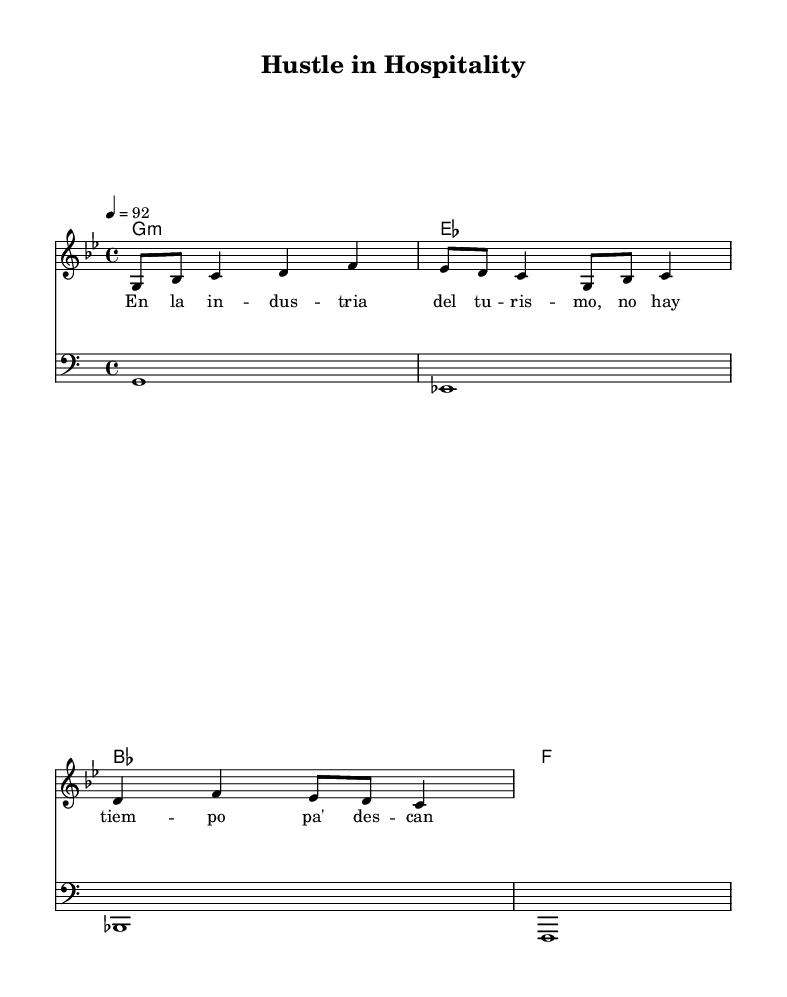What is the key signature of this music? The key signature is G minor, which has two flats (B♭ and E♭). This can be determined by looking at the key signature indication at the beginning of the staff.
Answer: G minor What is the time signature of this music? The time signature is 4/4, which can be found next to the key signature at the start of the sheet music. This means there are four beats per measure and the quarter note gets one beat.
Answer: 4/4 What is the tempo marking for this piece? The tempo marking indicates a speed of 92 beats per minute, as shown by the "4 = 92" marking. This refers to the quarter note being played at a tempo of 92 beats per minute.
Answer: 92 How many measures are in the melody section? The melody section consists of 4 measures, which can be counted based on the horizontal bars separating each segment of music in the staff.
Answer: 4 What type of chord progression is used in this piece? The chord progression consists of minor and major chords, specifically G minor, E♭ major, B♭ major, and F major. This can be deduced by examining the chordmode line which outlines the sequence of chords written above the melody.
Answer: Minor and major chords What is the main theme expressed in the lyrics? The main theme expressed in the lyrics relates to the hustle and dedication required in the tourism industry. Analyzing the lyrics shows a focus on assertiveness and determination in the hospitality field.
Answer: Hustle and determination Which clef is used for the bassline? The bassline uses the bass clef, which can be identified at the beginning of the bassline staff where the bass clef symbol is placed, indicating the pitch range for lower notes.
Answer: Bass clef 